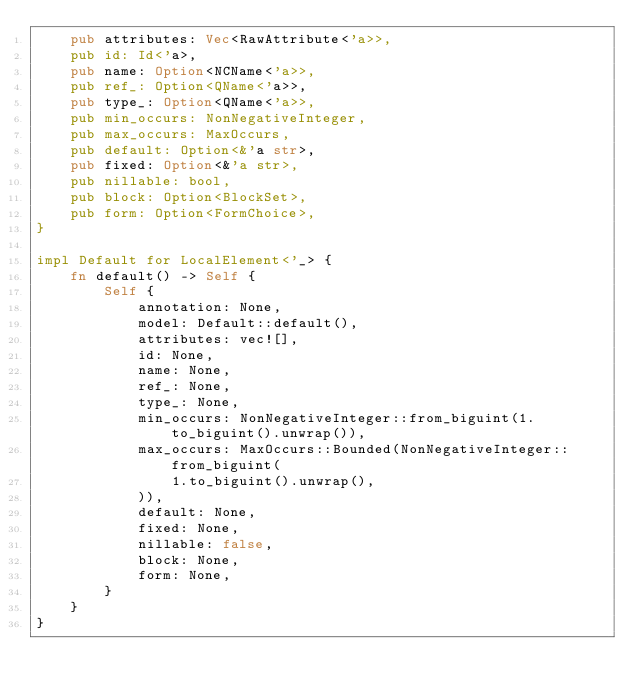Convert code to text. <code><loc_0><loc_0><loc_500><loc_500><_Rust_>    pub attributes: Vec<RawAttribute<'a>>,
    pub id: Id<'a>,
    pub name: Option<NCName<'a>>,
    pub ref_: Option<QName<'a>>,
    pub type_: Option<QName<'a>>,
    pub min_occurs: NonNegativeInteger,
    pub max_occurs: MaxOccurs,
    pub default: Option<&'a str>,
    pub fixed: Option<&'a str>,
    pub nillable: bool,
    pub block: Option<BlockSet>,
    pub form: Option<FormChoice>,
}

impl Default for LocalElement<'_> {
    fn default() -> Self {
        Self {
            annotation: None,
            model: Default::default(),
            attributes: vec![],
            id: None,
            name: None,
            ref_: None,
            type_: None,
            min_occurs: NonNegativeInteger::from_biguint(1.to_biguint().unwrap()),
            max_occurs: MaxOccurs::Bounded(NonNegativeInteger::from_biguint(
                1.to_biguint().unwrap(),
            )),
            default: None,
            fixed: None,
            nillable: false,
            block: None,
            form: None,
        }
    }
}
</code> 